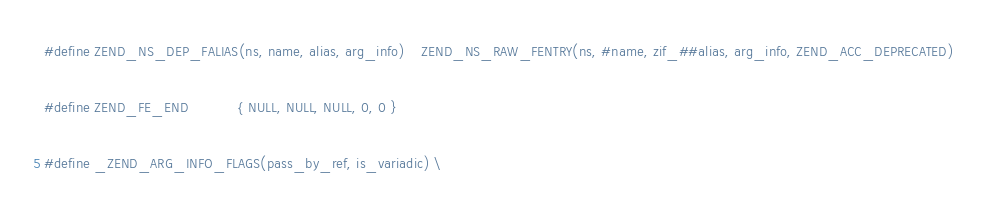<code> <loc_0><loc_0><loc_500><loc_500><_C_>#define ZEND_NS_DEP_FALIAS(ns, name, alias, arg_info)	ZEND_NS_RAW_FENTRY(ns, #name, zif_##alias, arg_info, ZEND_ACC_DEPRECATED)

#define ZEND_FE_END            { NULL, NULL, NULL, 0, 0 }

#define _ZEND_ARG_INFO_FLAGS(pass_by_ref, is_variadic) \</code> 